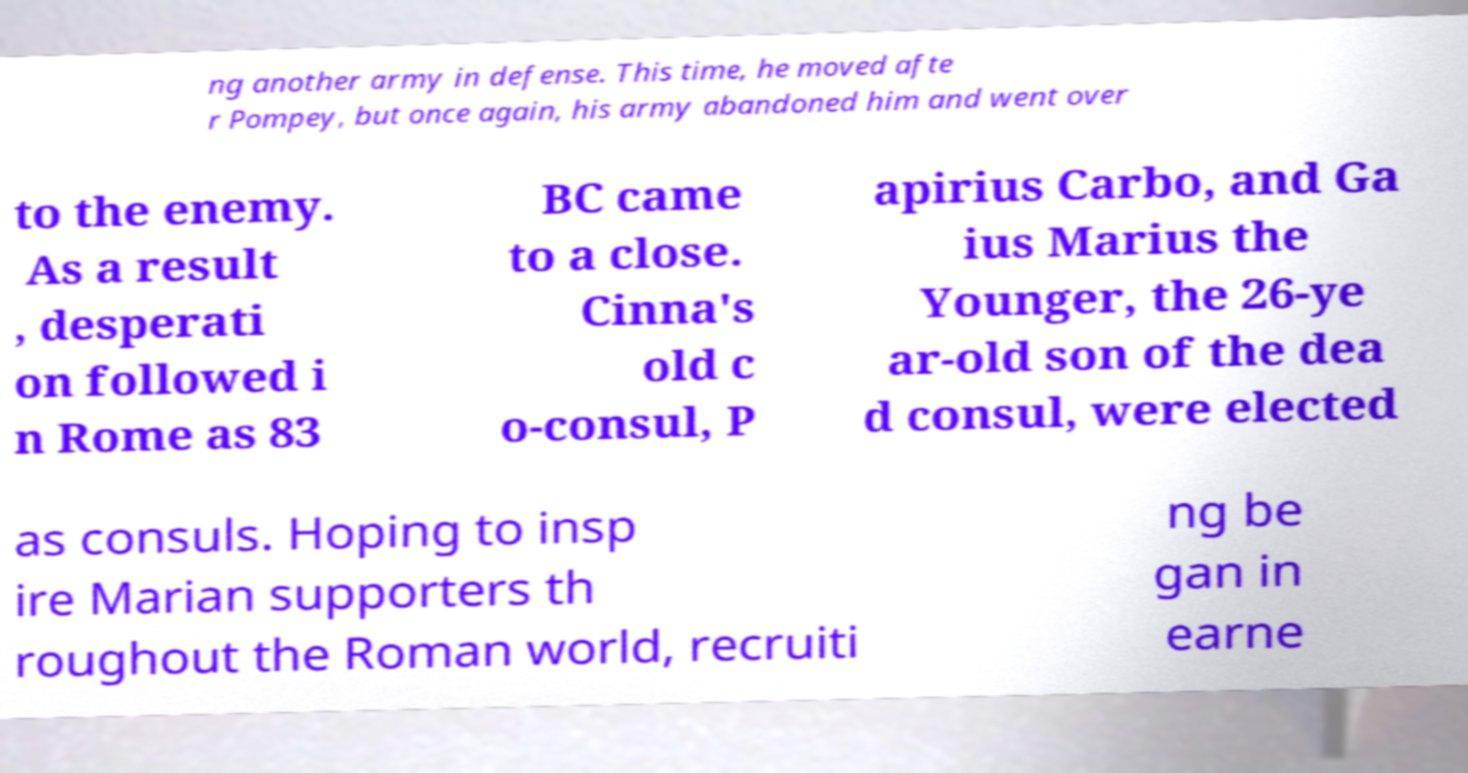Can you accurately transcribe the text from the provided image for me? ng another army in defense. This time, he moved afte r Pompey, but once again, his army abandoned him and went over to the enemy. As a result , desperati on followed i n Rome as 83 BC came to a close. Cinna's old c o-consul, P apirius Carbo, and Ga ius Marius the Younger, the 26-ye ar-old son of the dea d consul, were elected as consuls. Hoping to insp ire Marian supporters th roughout the Roman world, recruiti ng be gan in earne 